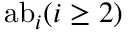Convert formula to latex. <formula><loc_0><loc_0><loc_500><loc_500>{ a b } _ { i } ( i \geq 2 )</formula> 